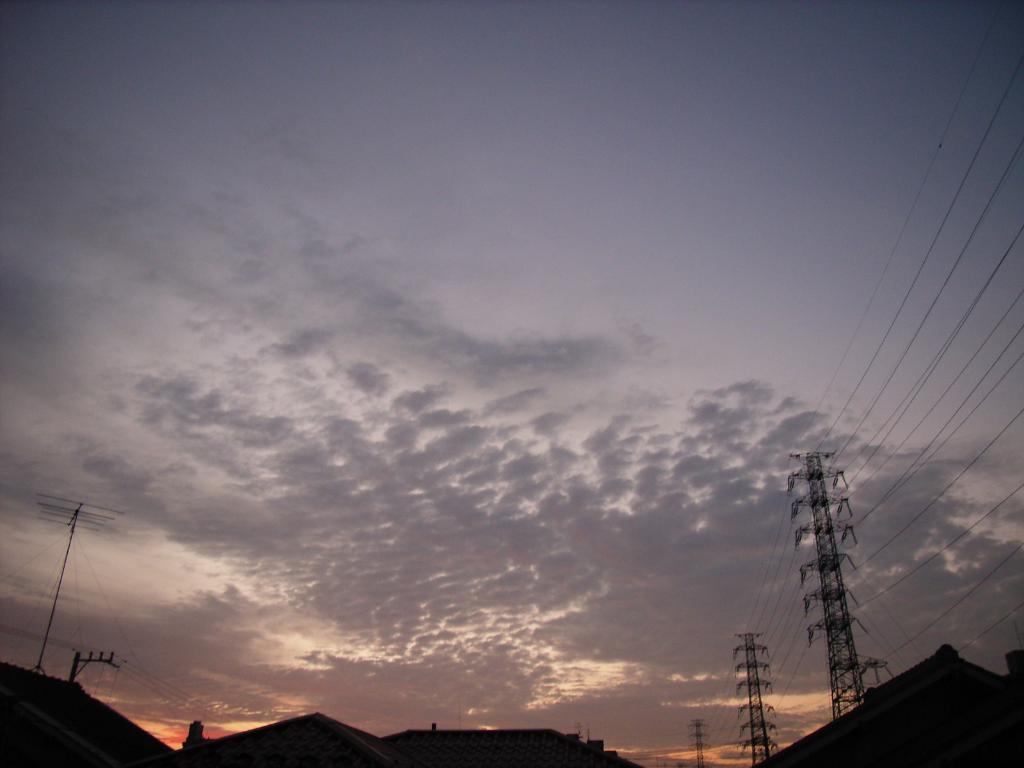In one or two sentences, can you explain what this image depicts? This is a landscape image where we can see some houses, current poles, wires and high tension poles at the bottom of the image, there are clouds in the sky. 